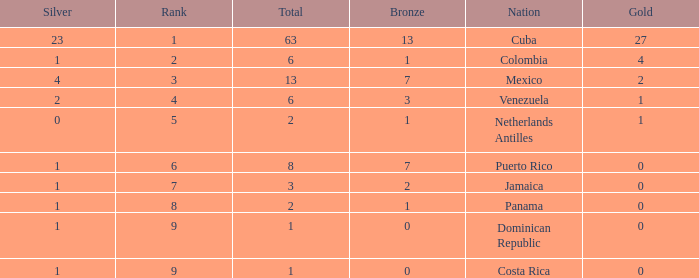What nation has the lowest gold average that has a rank over 9? None. 